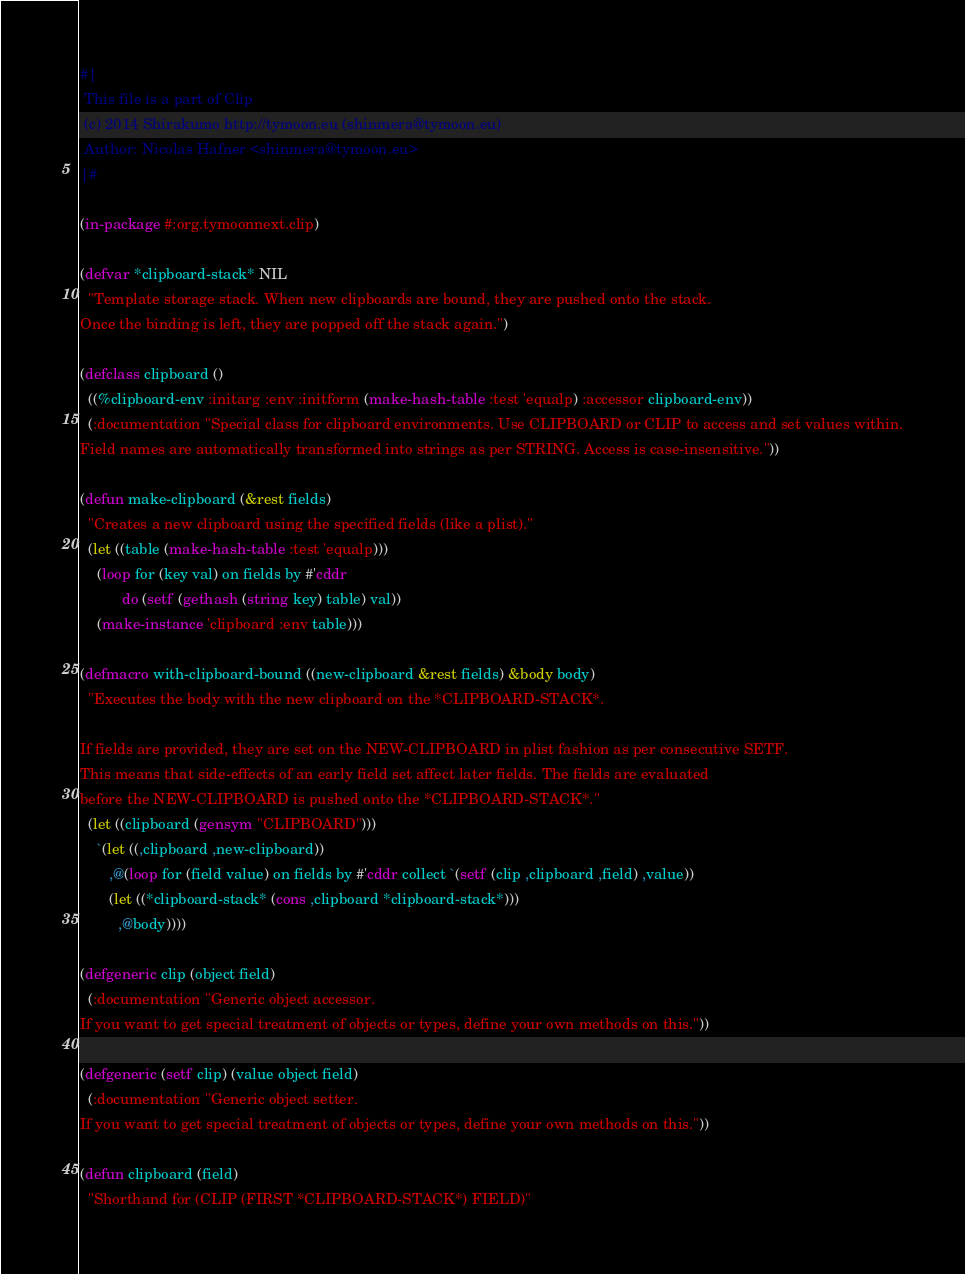<code> <loc_0><loc_0><loc_500><loc_500><_Lisp_>#|
 This file is a part of Clip
 (c) 2014 Shirakumo http://tymoon.eu (shinmera@tymoon.eu)
 Author: Nicolas Hafner <shinmera@tymoon.eu>
|#

(in-package #:org.tymoonnext.clip)

(defvar *clipboard-stack* NIL
  "Template storage stack. When new clipboards are bound, they are pushed onto the stack.
Once the binding is left, they are popped off the stack again.")

(defclass clipboard ()
  ((%clipboard-env :initarg :env :initform (make-hash-table :test 'equalp) :accessor clipboard-env))
  (:documentation "Special class for clipboard environments. Use CLIPBOARD or CLIP to access and set values within.
Field names are automatically transformed into strings as per STRING. Access is case-insensitive."))

(defun make-clipboard (&rest fields)
  "Creates a new clipboard using the specified fields (like a plist)."
  (let ((table (make-hash-table :test 'equalp)))
    (loop for (key val) on fields by #'cddr
          do (setf (gethash (string key) table) val))
    (make-instance 'clipboard :env table)))

(defmacro with-clipboard-bound ((new-clipboard &rest fields) &body body)
  "Executes the body with the new clipboard on the *CLIPBOARD-STACK*.

If fields are provided, they are set on the NEW-CLIPBOARD in plist fashion as per consecutive SETF.
This means that side-effects of an early field set affect later fields. The fields are evaluated
before the NEW-CLIPBOARD is pushed onto the *CLIPBOARD-STACK*."
  (let ((clipboard (gensym "CLIPBOARD")))
    `(let ((,clipboard ,new-clipboard))
       ,@(loop for (field value) on fields by #'cddr collect `(setf (clip ,clipboard ,field) ,value))
       (let ((*clipboard-stack* (cons ,clipboard *clipboard-stack*)))
         ,@body))))

(defgeneric clip (object field)
  (:documentation "Generic object accessor.
If you want to get special treatment of objects or types, define your own methods on this."))

(defgeneric (setf clip) (value object field)
  (:documentation "Generic object setter.
If you want to get special treatment of objects or types, define your own methods on this."))

(defun clipboard (field)
  "Shorthand for (CLIP (FIRST *CLIPBOARD-STACK*) FIELD)"</code> 